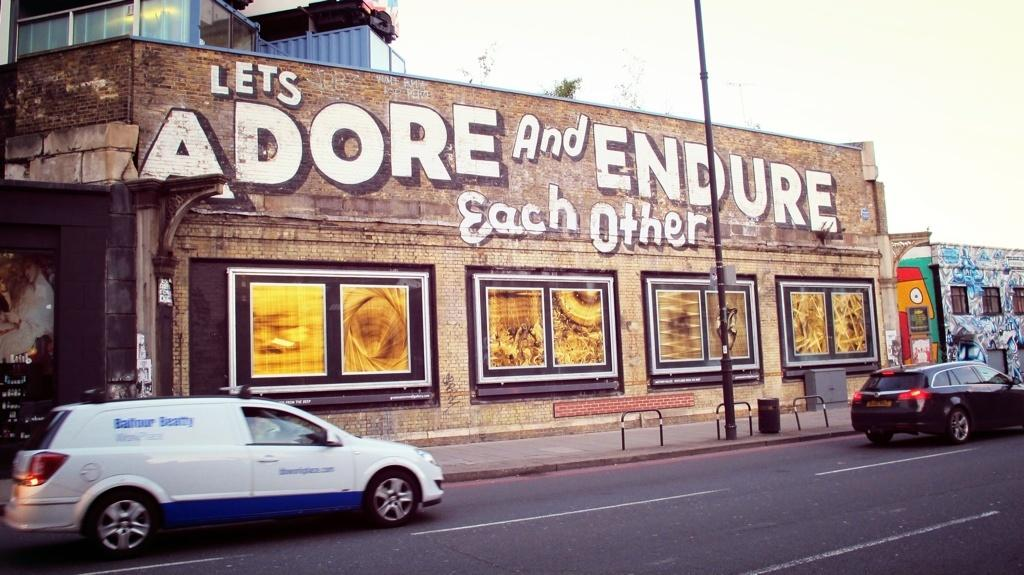What type of structures can be seen in the image? There are houses in the image. What decorative items are present in the image? There are posters and paintings in the image. What architectural feature is visible in the image? There is a wall in the image. How many vehicles are on the road in the image? Two vehicles are on the road in the image. What vertical structure is present in the image? There is a pole in the image. What objects are used for support or attachment in the image? There are rods in the image. What object is used for waste disposal in the image? There is a dustbin in the image. How many tomatoes are hanging from the pole in the image? There are no tomatoes present in the image; only a pole is visible. What type of cattle can be seen grazing near the houses in the image? There are no cattle present in the image; only houses, posters, paintings, a wall, vehicles, a pole, rods, and a dustbin are visible. 